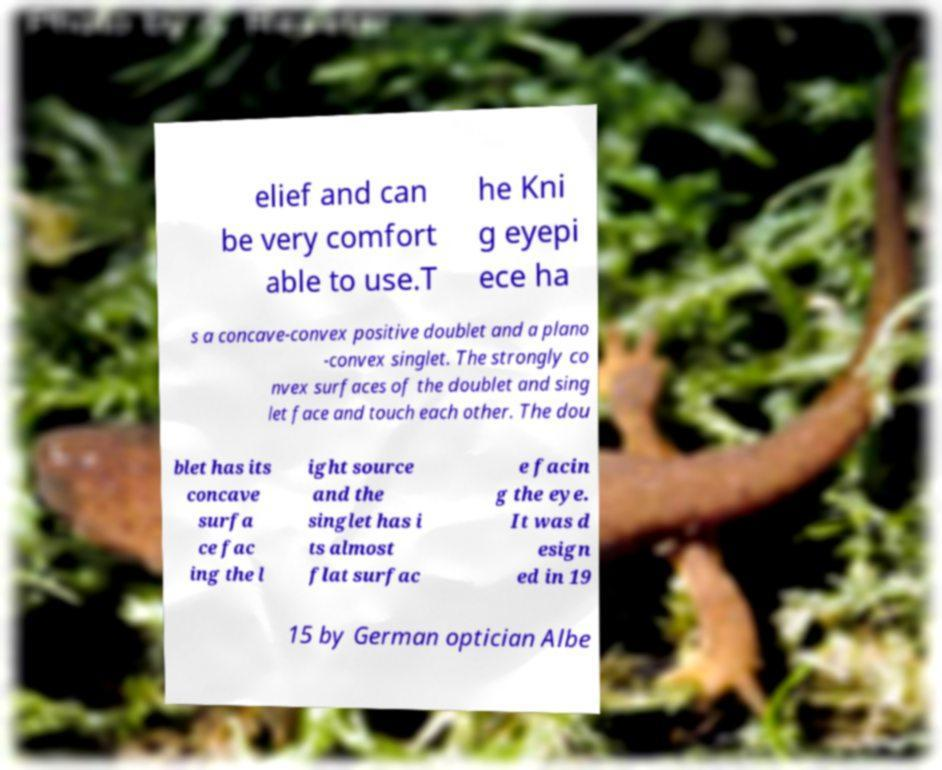There's text embedded in this image that I need extracted. Can you transcribe it verbatim? elief and can be very comfort able to use.T he Kni g eyepi ece ha s a concave-convex positive doublet and a plano -convex singlet. The strongly co nvex surfaces of the doublet and sing let face and touch each other. The dou blet has its concave surfa ce fac ing the l ight source and the singlet has i ts almost flat surfac e facin g the eye. It was d esign ed in 19 15 by German optician Albe 